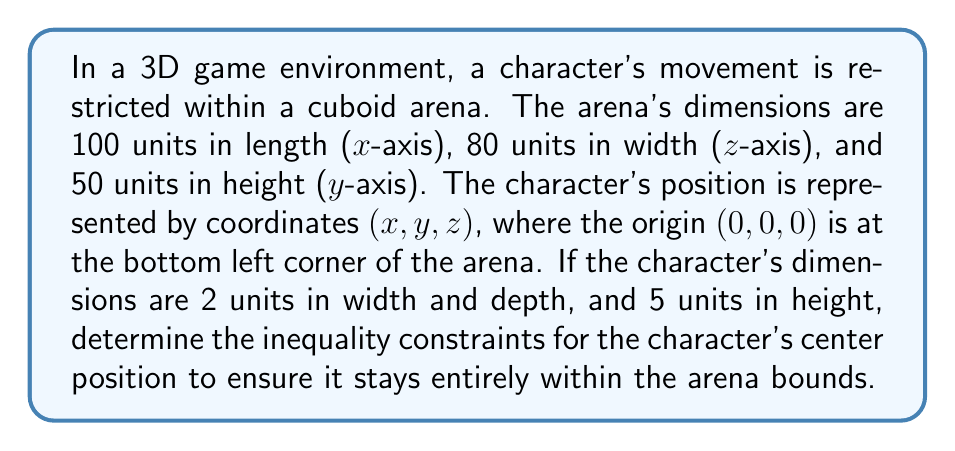Help me with this question. To solve this problem, we need to consider the character's dimensions and the arena's boundaries:

1. X-axis constraints:
   - The character's width is 2 units, so its center must be at least 1 unit away from each side.
   - Left boundary: $x \geq 1$
   - Right boundary: $x \leq 99$ (100 - 1)

2. Z-axis constraints:
   - Similar to the x-axis, the character's depth is 2 units.
   - Front boundary: $z \geq 1$
   - Back boundary: $z \leq 79$ (80 - 1)

3. Y-axis constraints:
   - The character's height is 5 units, so its center must be at least 2.5 units from the bottom and top.
   - Bottom boundary: $y \geq 2.5$
   - Top boundary: $y \leq 47.5$ (50 - 2.5)

Combining these constraints, we get the following system of inequalities:

$$
\begin{cases}
1 \leq x \leq 99 \\
2.5 \leq y \leq 47.5 \\
1 \leq z \leq 79
\end{cases}
$$

This system of inequalities defines the boundaries for the character's center position, ensuring it stays entirely within the arena.
Answer: $$
\begin{cases}
1 \leq x \leq 99 \\
2.5 \leq y \leq 47.5 \\
1 \leq z \leq 79
\end{cases}
$$ 